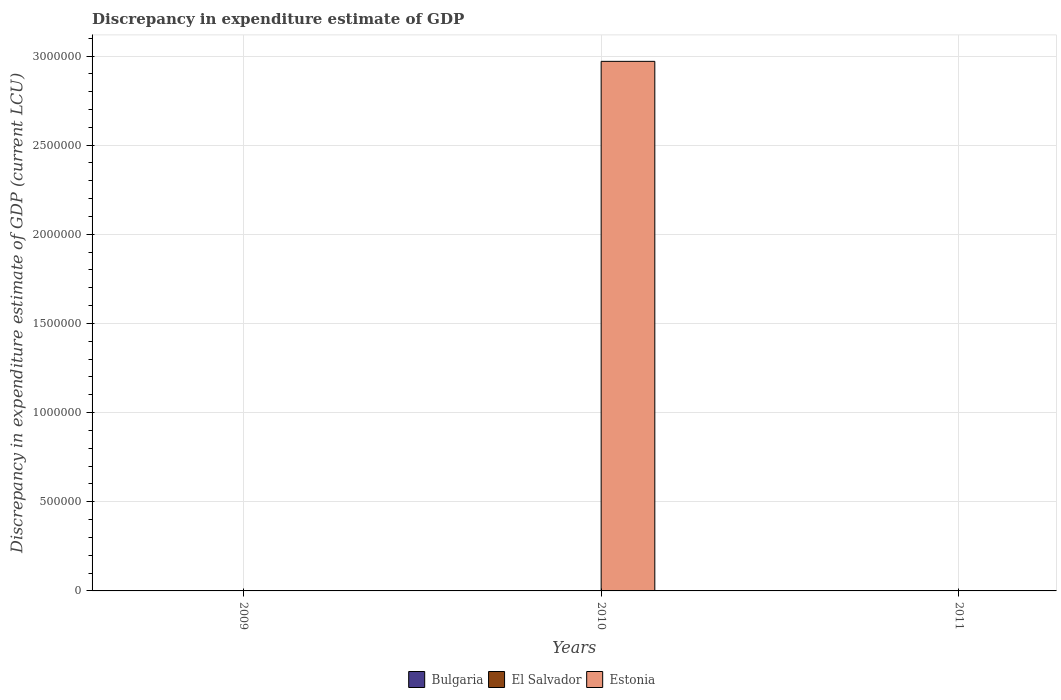How many different coloured bars are there?
Provide a succinct answer. 2. How many bars are there on the 3rd tick from the left?
Provide a succinct answer. 2. What is the label of the 1st group of bars from the left?
Your answer should be compact. 2009. Across all years, what is the maximum discrepancy in expenditure estimate of GDP in Bulgaria?
Offer a very short reply. 1e-5. Across all years, what is the minimum discrepancy in expenditure estimate of GDP in El Salvador?
Your answer should be compact. 0. What is the total discrepancy in expenditure estimate of GDP in Bulgaria in the graph?
Offer a very short reply. 1.6000000000000003e-5. What is the difference between the discrepancy in expenditure estimate of GDP in Estonia in 2010 and that in 2011?
Your response must be concise. 2.97e+06. What is the difference between the discrepancy in expenditure estimate of GDP in Estonia in 2010 and the discrepancy in expenditure estimate of GDP in Bulgaria in 2009?
Keep it short and to the point. 2.97e+06. What is the average discrepancy in expenditure estimate of GDP in Bulgaria per year?
Give a very brief answer. 5.3333333333333345e-6. In the year 2011, what is the difference between the discrepancy in expenditure estimate of GDP in Bulgaria and discrepancy in expenditure estimate of GDP in Estonia?
Give a very brief answer. 8.0926513671875e-6. What is the ratio of the discrepancy in expenditure estimate of GDP in Bulgaria in 2009 to that in 2011?
Your answer should be compact. 0.6. Is the discrepancy in expenditure estimate of GDP in Estonia in 2010 less than that in 2011?
Keep it short and to the point. No. What is the difference between the highest and the lowest discrepancy in expenditure estimate of GDP in Estonia?
Provide a short and direct response. 2.97e+06. Is the sum of the discrepancy in expenditure estimate of GDP in Estonia in 2010 and 2011 greater than the maximum discrepancy in expenditure estimate of GDP in El Salvador across all years?
Offer a terse response. Yes. Is it the case that in every year, the sum of the discrepancy in expenditure estimate of GDP in Bulgaria and discrepancy in expenditure estimate of GDP in Estonia is greater than the discrepancy in expenditure estimate of GDP in El Salvador?
Provide a short and direct response. Yes. How many bars are there?
Your answer should be compact. 4. Are all the bars in the graph horizontal?
Your answer should be compact. No. What is the difference between two consecutive major ticks on the Y-axis?
Your response must be concise. 5.00e+05. How many legend labels are there?
Your response must be concise. 3. What is the title of the graph?
Provide a short and direct response. Discrepancy in expenditure estimate of GDP. Does "Malaysia" appear as one of the legend labels in the graph?
Offer a terse response. No. What is the label or title of the Y-axis?
Your answer should be compact. Discrepancy in expenditure estimate of GDP (current LCU). What is the Discrepancy in expenditure estimate of GDP (current LCU) in Bulgaria in 2009?
Ensure brevity in your answer.  6e-6. What is the Discrepancy in expenditure estimate of GDP (current LCU) in Estonia in 2009?
Offer a very short reply. 0. What is the Discrepancy in expenditure estimate of GDP (current LCU) in El Salvador in 2010?
Give a very brief answer. 0. What is the Discrepancy in expenditure estimate of GDP (current LCU) of Estonia in 2010?
Your response must be concise. 2.97e+06. What is the Discrepancy in expenditure estimate of GDP (current LCU) in Bulgaria in 2011?
Give a very brief answer. 1e-5. What is the Discrepancy in expenditure estimate of GDP (current LCU) of Estonia in 2011?
Provide a succinct answer. 1.9073486328125e-6. Across all years, what is the maximum Discrepancy in expenditure estimate of GDP (current LCU) of Bulgaria?
Ensure brevity in your answer.  1e-5. Across all years, what is the maximum Discrepancy in expenditure estimate of GDP (current LCU) in Estonia?
Provide a short and direct response. 2.97e+06. Across all years, what is the minimum Discrepancy in expenditure estimate of GDP (current LCU) in Bulgaria?
Make the answer very short. 0. What is the total Discrepancy in expenditure estimate of GDP (current LCU) in El Salvador in the graph?
Make the answer very short. 0. What is the total Discrepancy in expenditure estimate of GDP (current LCU) in Estonia in the graph?
Your response must be concise. 2.97e+06. What is the difference between the Discrepancy in expenditure estimate of GDP (current LCU) in Bulgaria in 2009 and that in 2011?
Offer a terse response. -0. What is the difference between the Discrepancy in expenditure estimate of GDP (current LCU) of Estonia in 2010 and that in 2011?
Your answer should be compact. 2.97e+06. What is the difference between the Discrepancy in expenditure estimate of GDP (current LCU) in Bulgaria in 2009 and the Discrepancy in expenditure estimate of GDP (current LCU) in Estonia in 2010?
Your response must be concise. -2.97e+06. What is the difference between the Discrepancy in expenditure estimate of GDP (current LCU) of Bulgaria in 2009 and the Discrepancy in expenditure estimate of GDP (current LCU) of Estonia in 2011?
Keep it short and to the point. 0. What is the average Discrepancy in expenditure estimate of GDP (current LCU) of Estonia per year?
Provide a succinct answer. 9.90e+05. What is the ratio of the Discrepancy in expenditure estimate of GDP (current LCU) in Bulgaria in 2009 to that in 2011?
Provide a succinct answer. 0.6. What is the ratio of the Discrepancy in expenditure estimate of GDP (current LCU) of Estonia in 2010 to that in 2011?
Provide a short and direct response. 1.56e+12. What is the difference between the highest and the lowest Discrepancy in expenditure estimate of GDP (current LCU) in Bulgaria?
Offer a terse response. 0. What is the difference between the highest and the lowest Discrepancy in expenditure estimate of GDP (current LCU) of Estonia?
Offer a terse response. 2.97e+06. 